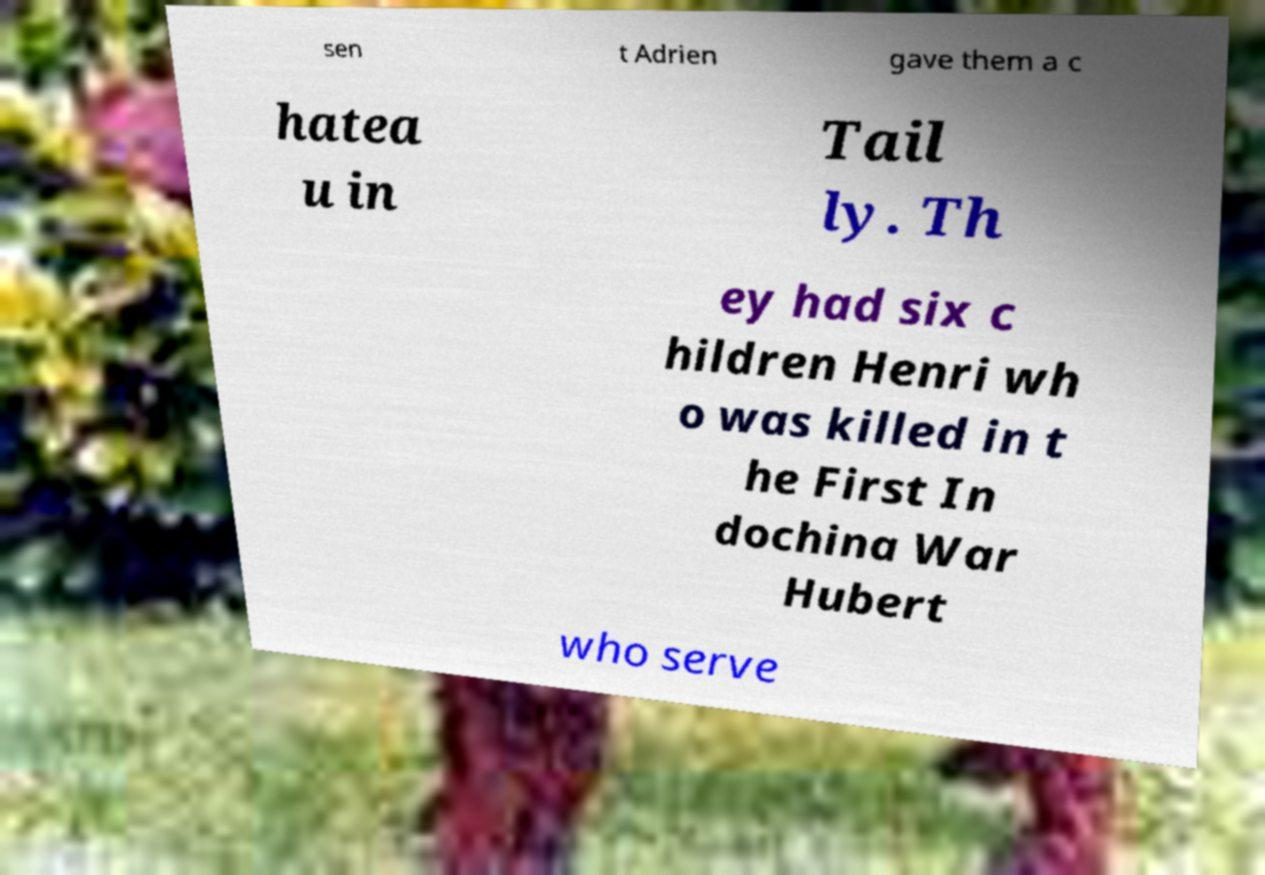Please read and relay the text visible in this image. What does it say? sen t Adrien gave them a c hatea u in Tail ly. Th ey had six c hildren Henri wh o was killed in t he First In dochina War Hubert who serve 